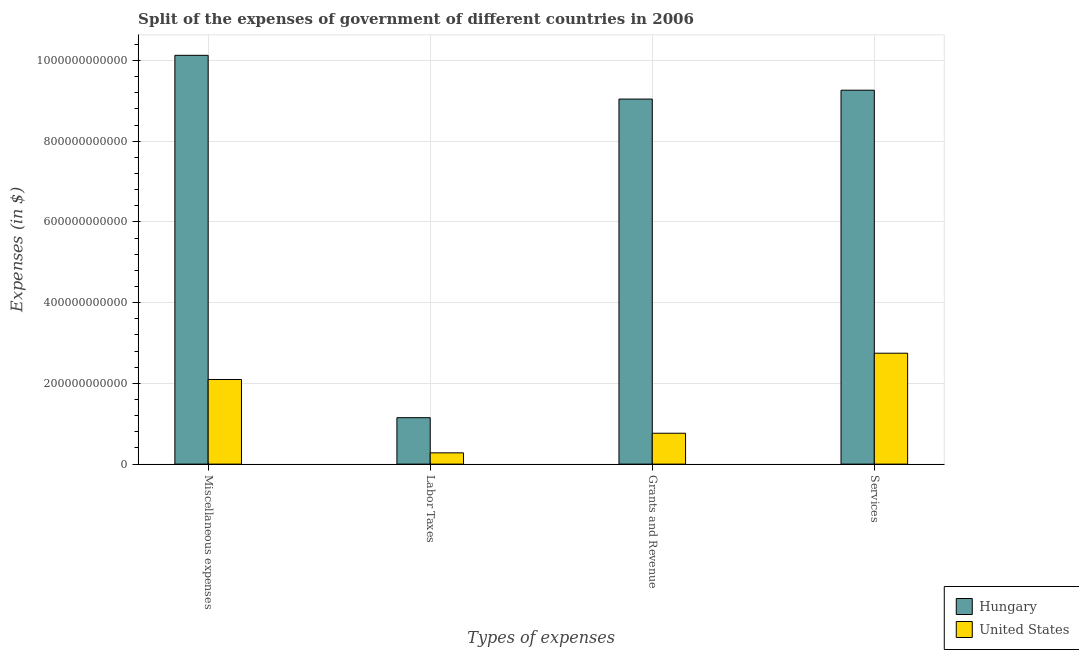How many different coloured bars are there?
Give a very brief answer. 2. How many groups of bars are there?
Your answer should be very brief. 4. Are the number of bars per tick equal to the number of legend labels?
Give a very brief answer. Yes. How many bars are there on the 3rd tick from the right?
Ensure brevity in your answer.  2. What is the label of the 3rd group of bars from the left?
Your response must be concise. Grants and Revenue. What is the amount spent on miscellaneous expenses in United States?
Provide a short and direct response. 2.10e+11. Across all countries, what is the maximum amount spent on miscellaneous expenses?
Ensure brevity in your answer.  1.01e+12. Across all countries, what is the minimum amount spent on labor taxes?
Provide a succinct answer. 2.79e+1. In which country was the amount spent on grants and revenue maximum?
Provide a short and direct response. Hungary. In which country was the amount spent on labor taxes minimum?
Give a very brief answer. United States. What is the total amount spent on grants and revenue in the graph?
Give a very brief answer. 9.81e+11. What is the difference between the amount spent on services in Hungary and that in United States?
Provide a succinct answer. 6.52e+11. What is the difference between the amount spent on services in Hungary and the amount spent on miscellaneous expenses in United States?
Offer a very short reply. 7.17e+11. What is the average amount spent on labor taxes per country?
Your response must be concise. 7.15e+1. What is the difference between the amount spent on grants and revenue and amount spent on services in United States?
Ensure brevity in your answer.  -1.98e+11. What is the ratio of the amount spent on services in Hungary to that in United States?
Keep it short and to the point. 3.37. What is the difference between the highest and the second highest amount spent on services?
Offer a terse response. 6.52e+11. What is the difference between the highest and the lowest amount spent on grants and revenue?
Offer a terse response. 8.28e+11. In how many countries, is the amount spent on services greater than the average amount spent on services taken over all countries?
Your response must be concise. 1. What does the 1st bar from the left in Miscellaneous expenses represents?
Provide a succinct answer. Hungary. What does the 2nd bar from the right in Miscellaneous expenses represents?
Your response must be concise. Hungary. Is it the case that in every country, the sum of the amount spent on miscellaneous expenses and amount spent on labor taxes is greater than the amount spent on grants and revenue?
Make the answer very short. Yes. What is the difference between two consecutive major ticks on the Y-axis?
Ensure brevity in your answer.  2.00e+11. Does the graph contain grids?
Your answer should be very brief. Yes. Where does the legend appear in the graph?
Provide a succinct answer. Bottom right. How are the legend labels stacked?
Offer a very short reply. Vertical. What is the title of the graph?
Keep it short and to the point. Split of the expenses of government of different countries in 2006. What is the label or title of the X-axis?
Give a very brief answer. Types of expenses. What is the label or title of the Y-axis?
Offer a very short reply. Expenses (in $). What is the Expenses (in $) of Hungary in Miscellaneous expenses?
Provide a succinct answer. 1.01e+12. What is the Expenses (in $) in United States in Miscellaneous expenses?
Your response must be concise. 2.10e+11. What is the Expenses (in $) of Hungary in Labor Taxes?
Your answer should be very brief. 1.15e+11. What is the Expenses (in $) in United States in Labor Taxes?
Offer a very short reply. 2.79e+1. What is the Expenses (in $) of Hungary in Grants and Revenue?
Keep it short and to the point. 9.05e+11. What is the Expenses (in $) of United States in Grants and Revenue?
Offer a terse response. 7.65e+1. What is the Expenses (in $) of Hungary in Services?
Your response must be concise. 9.26e+11. What is the Expenses (in $) of United States in Services?
Keep it short and to the point. 2.75e+11. Across all Types of expenses, what is the maximum Expenses (in $) in Hungary?
Provide a succinct answer. 1.01e+12. Across all Types of expenses, what is the maximum Expenses (in $) in United States?
Keep it short and to the point. 2.75e+11. Across all Types of expenses, what is the minimum Expenses (in $) of Hungary?
Offer a very short reply. 1.15e+11. Across all Types of expenses, what is the minimum Expenses (in $) of United States?
Give a very brief answer. 2.79e+1. What is the total Expenses (in $) in Hungary in the graph?
Provide a succinct answer. 2.96e+12. What is the total Expenses (in $) in United States in the graph?
Make the answer very short. 5.89e+11. What is the difference between the Expenses (in $) in Hungary in Miscellaneous expenses and that in Labor Taxes?
Offer a terse response. 8.98e+11. What is the difference between the Expenses (in $) of United States in Miscellaneous expenses and that in Labor Taxes?
Give a very brief answer. 1.82e+11. What is the difference between the Expenses (in $) of Hungary in Miscellaneous expenses and that in Grants and Revenue?
Give a very brief answer. 1.08e+11. What is the difference between the Expenses (in $) of United States in Miscellaneous expenses and that in Grants and Revenue?
Make the answer very short. 1.33e+11. What is the difference between the Expenses (in $) of Hungary in Miscellaneous expenses and that in Services?
Keep it short and to the point. 8.65e+1. What is the difference between the Expenses (in $) in United States in Miscellaneous expenses and that in Services?
Provide a short and direct response. -6.51e+1. What is the difference between the Expenses (in $) of Hungary in Labor Taxes and that in Grants and Revenue?
Your answer should be compact. -7.89e+11. What is the difference between the Expenses (in $) in United States in Labor Taxes and that in Grants and Revenue?
Give a very brief answer. -4.86e+1. What is the difference between the Expenses (in $) in Hungary in Labor Taxes and that in Services?
Your response must be concise. -8.11e+11. What is the difference between the Expenses (in $) in United States in Labor Taxes and that in Services?
Offer a very short reply. -2.47e+11. What is the difference between the Expenses (in $) in Hungary in Grants and Revenue and that in Services?
Your answer should be compact. -2.20e+1. What is the difference between the Expenses (in $) of United States in Grants and Revenue and that in Services?
Your response must be concise. -1.98e+11. What is the difference between the Expenses (in $) of Hungary in Miscellaneous expenses and the Expenses (in $) of United States in Labor Taxes?
Provide a short and direct response. 9.85e+11. What is the difference between the Expenses (in $) of Hungary in Miscellaneous expenses and the Expenses (in $) of United States in Grants and Revenue?
Provide a short and direct response. 9.36e+11. What is the difference between the Expenses (in $) in Hungary in Miscellaneous expenses and the Expenses (in $) in United States in Services?
Provide a short and direct response. 7.38e+11. What is the difference between the Expenses (in $) in Hungary in Labor Taxes and the Expenses (in $) in United States in Grants and Revenue?
Your response must be concise. 3.86e+1. What is the difference between the Expenses (in $) of Hungary in Labor Taxes and the Expenses (in $) of United States in Services?
Your answer should be very brief. -1.60e+11. What is the difference between the Expenses (in $) in Hungary in Grants and Revenue and the Expenses (in $) in United States in Services?
Provide a succinct answer. 6.30e+11. What is the average Expenses (in $) of Hungary per Types of expenses?
Your response must be concise. 7.40e+11. What is the average Expenses (in $) in United States per Types of expenses?
Offer a terse response. 1.47e+11. What is the difference between the Expenses (in $) in Hungary and Expenses (in $) in United States in Miscellaneous expenses?
Ensure brevity in your answer.  8.03e+11. What is the difference between the Expenses (in $) in Hungary and Expenses (in $) in United States in Labor Taxes?
Make the answer very short. 8.72e+1. What is the difference between the Expenses (in $) in Hungary and Expenses (in $) in United States in Grants and Revenue?
Provide a succinct answer. 8.28e+11. What is the difference between the Expenses (in $) in Hungary and Expenses (in $) in United States in Services?
Ensure brevity in your answer.  6.52e+11. What is the ratio of the Expenses (in $) in Hungary in Miscellaneous expenses to that in Labor Taxes?
Ensure brevity in your answer.  8.8. What is the ratio of the Expenses (in $) in United States in Miscellaneous expenses to that in Labor Taxes?
Your answer should be very brief. 7.52. What is the ratio of the Expenses (in $) in Hungary in Miscellaneous expenses to that in Grants and Revenue?
Your answer should be compact. 1.12. What is the ratio of the Expenses (in $) of United States in Miscellaneous expenses to that in Grants and Revenue?
Make the answer very short. 2.74. What is the ratio of the Expenses (in $) in Hungary in Miscellaneous expenses to that in Services?
Your response must be concise. 1.09. What is the ratio of the Expenses (in $) of United States in Miscellaneous expenses to that in Services?
Offer a terse response. 0.76. What is the ratio of the Expenses (in $) in Hungary in Labor Taxes to that in Grants and Revenue?
Provide a succinct answer. 0.13. What is the ratio of the Expenses (in $) in United States in Labor Taxes to that in Grants and Revenue?
Your response must be concise. 0.36. What is the ratio of the Expenses (in $) in Hungary in Labor Taxes to that in Services?
Your response must be concise. 0.12. What is the ratio of the Expenses (in $) in United States in Labor Taxes to that in Services?
Keep it short and to the point. 0.1. What is the ratio of the Expenses (in $) of Hungary in Grants and Revenue to that in Services?
Provide a succinct answer. 0.98. What is the ratio of the Expenses (in $) of United States in Grants and Revenue to that in Services?
Provide a succinct answer. 0.28. What is the difference between the highest and the second highest Expenses (in $) of Hungary?
Your response must be concise. 8.65e+1. What is the difference between the highest and the second highest Expenses (in $) of United States?
Ensure brevity in your answer.  6.51e+1. What is the difference between the highest and the lowest Expenses (in $) in Hungary?
Offer a very short reply. 8.98e+11. What is the difference between the highest and the lowest Expenses (in $) in United States?
Give a very brief answer. 2.47e+11. 